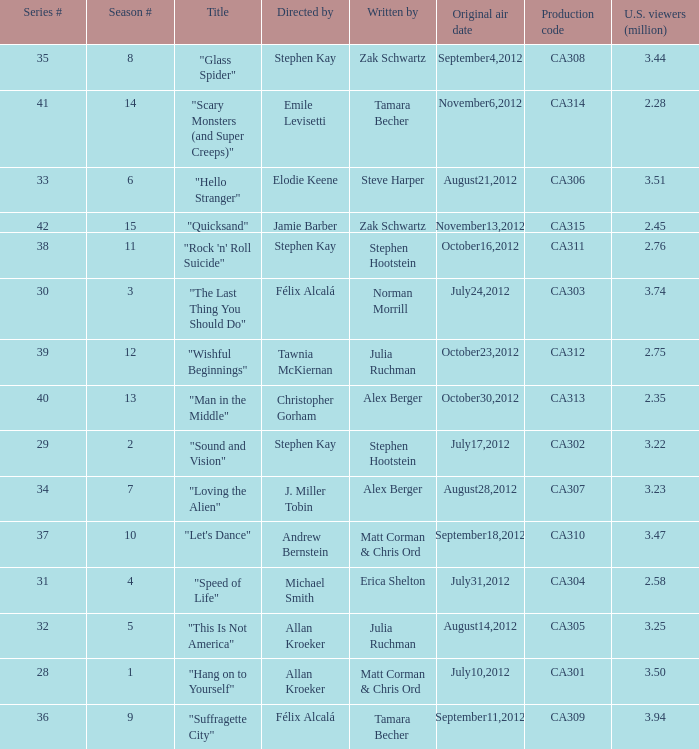What is the series episode number of the episode titled "sound and vision"? 29.0. 